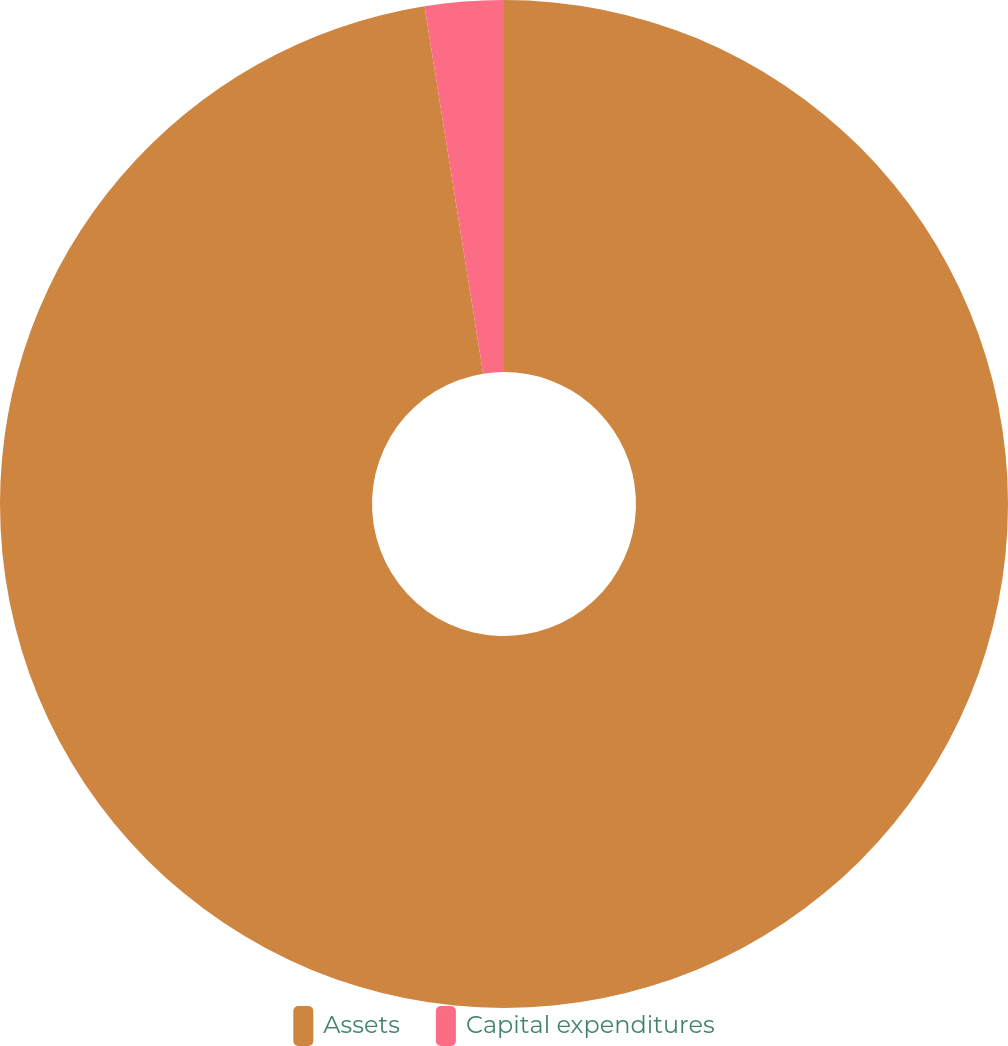Convert chart to OTSL. <chart><loc_0><loc_0><loc_500><loc_500><pie_chart><fcel>Assets<fcel>Capital expenditures<nl><fcel>97.48%<fcel>2.52%<nl></chart> 